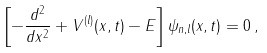<formula> <loc_0><loc_0><loc_500><loc_500>\left [ - \frac { d ^ { 2 } } { d x ^ { 2 } } + V ^ { ( l ) } ( x , t ) - E \right ] \psi _ { n , l } ( x , t ) = 0 \, ,</formula> 